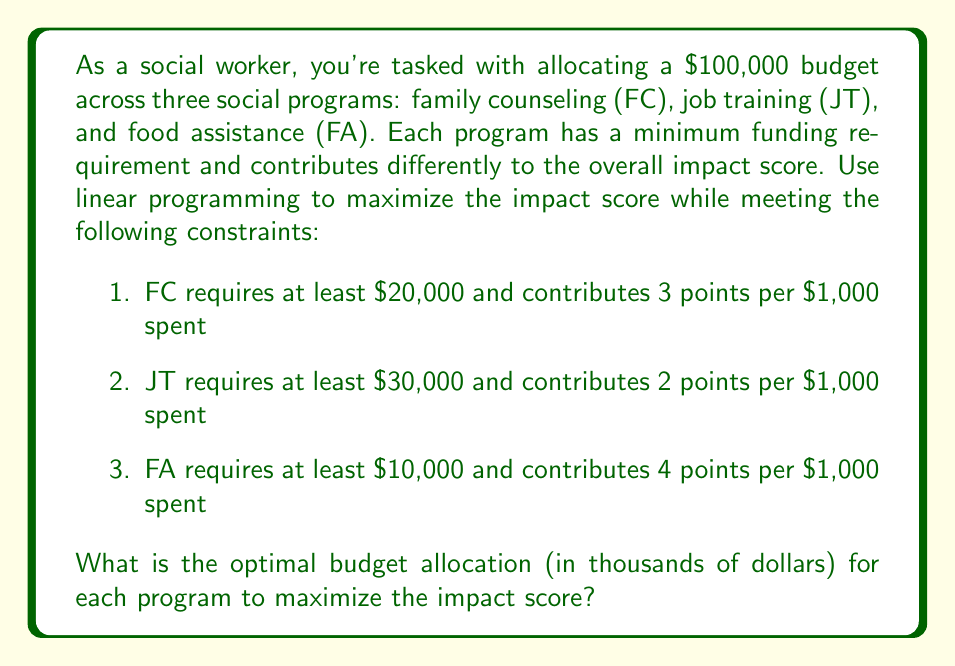Teach me how to tackle this problem. Let's solve this step-by-step using linear programming:

1. Define variables:
   Let $x$ = FC funding (in thousands)
   Let $y$ = JT funding (in thousands)
   Let $z$ = FA funding (in thousands)

2. Objective function (maximize impact score):
   $\text{Maximize } 3x + 2y + 4z$

3. Constraints:
   $x + y + z \leq 100$ (total budget)
   $x \geq 20$ (FC minimum)
   $y \geq 30$ (JT minimum)
   $z \geq 10$ (FA minimum)
   $x, y, z \geq 0$ (non-negativity)

4. Solve using the simplex method or graphical method. In this case, we can use reasoning:

   - FA has the highest impact per dollar, so we should maximize it after meeting other constraints.
   - JT has the lowest impact, so we should keep it at its minimum.
   - FC is in between, so we'll use it to balance the budget.

5. Optimal solution:
   $y = 30$ (JT at minimum)
   $z = 60$ (FA maximized)
   $x = 10$ (FC takes the remainder)

6. Verify constraints:
   $10 + 30 + 60 = 100$ (total budget met)
   $10 \geq 20$ for FC (not met, adjust)
   $30 \geq 30$ for JT (met)
   $60 \geq 10$ for FA (met)

7. Adjust FC to meet its minimum:
   $x = 20$ (FC at minimum)
   $z = 50$ (FA reduced to balance)

8. Final allocation:
   FC: $20,000
   JT: $30,000
   FA: $50,000

9. Verify total: $20 + 30 + 50 = 100$ (budget constraint met)

10. Calculate impact score: $3(20) + 2(30) + 4(50) = 320$ points
Answer: FC: $20,000, JT: $30,000, FA: $50,000 